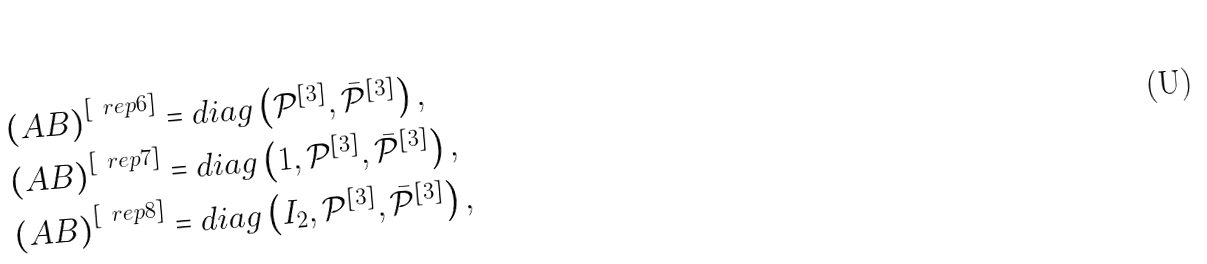<formula> <loc_0><loc_0><loc_500><loc_500>\left ( A B \right ) ^ { [ \ r e p { 6 } ] } & = d i a g \left ( \mathcal { P } ^ { \left [ 3 \right ] } , \bar { \mathcal { P } } ^ { [ 3 ] } \right ) , \\ \left ( A B \right ) ^ { [ \ r e p { 7 } ] } & = d i a g \left ( 1 , \mathcal { P } ^ { [ 3 ] } , \bar { \mathcal { P } } ^ { [ 3 ] } \right ) , \\ \left ( A B \right ) ^ { [ \ r e p { 8 } ] } & = d i a g \left ( I _ { 2 } , \mathcal { P } ^ { [ 3 ] } , \bar { \mathcal { P } } ^ { [ 3 ] } \right ) ,</formula> 